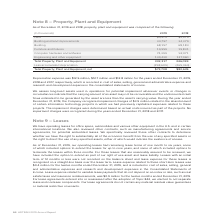According to Adtran's financial document, What was the depreciation expense in 2019? According to the financial document, $12.5 million. The relevant text states: "Depreciation expense was $12.5 million, $12.7 million and $12.8 million for the years ended December 31, 2019, 2018 and 2017, respectively..." Also, What was the  Total Property, Plant and Equipment, net in 2019? According to the financial document, $73,708 (in thousands). The relevant text states: "Total Property, Plant and Equipment, net $73,708 $80,635..." Also, What was the amount of building assets in 2019? According to the financial document, 68,157 (in thousands). The relevant text states: "Building 68,157 68,183..." Also, can you calculate: What was the change in furniture and fixtures between 2018 and 2019? Based on the calculation: 19,959-19,831, the result is 128 (in thousands). This is based on the information: "Furniture and fixtures 19,959 19,831 Furniture and fixtures 19,959 19,831..." The key data points involved are: 19,831, 19,959. Also, can you calculate: What was the change in engineering and other equipment between 2018 and 2019? Based on the calculation: 130,430-127,060, the result is 3370 (in thousands). This is based on the information: "Engineering and other equipment 130,430 127,060 Engineering and other equipment 130,430 127,060..." The key data points involved are: 127,060, 130,430. Also, can you calculate: What was the percentage change in net total property, plant and equipment between 2018 and 2019? To answer this question, I need to perform calculations using the financial data. The calculation is: ($73,708-$80,635)/$80,635, which equals -8.59 (percentage). This is based on the information: "Total Property, Plant and Equipment, net $73,708 $80,635 Total Property, Plant and Equipment, net $73,708 $80,635..." The key data points involved are: 73,708, 80,635. 